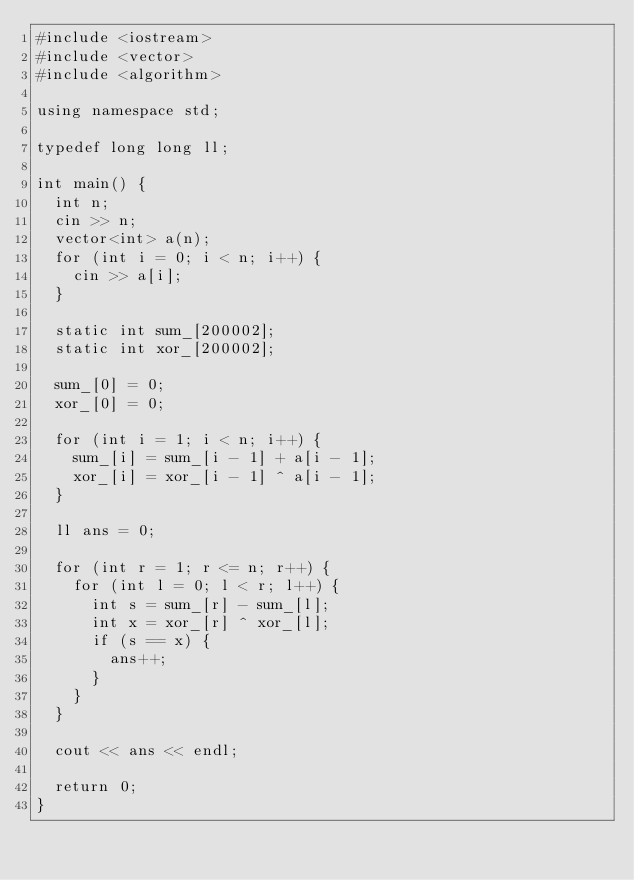Convert code to text. <code><loc_0><loc_0><loc_500><loc_500><_C++_>#include <iostream>
#include <vector>
#include <algorithm>

using namespace std;

typedef long long ll;

int main() {
  int n;
  cin >> n;
  vector<int> a(n);
  for (int i = 0; i < n; i++) {
    cin >> a[i];
  }

  static int sum_[200002];
  static int xor_[200002];
  
  sum_[0] = 0;
  xor_[0] = 0;

  for (int i = 1; i < n; i++) {
    sum_[i] = sum_[i - 1] + a[i - 1];
    xor_[i] = xor_[i - 1] ^ a[i - 1];
  }

  ll ans = 0;

  for (int r = 1; r <= n; r++) {
    for (int l = 0; l < r; l++) {
      int s = sum_[r] - sum_[l];
      int x = xor_[r] ^ xor_[l];
      if (s == x) {
        ans++;
      }
    }
  }

  cout << ans << endl;  

  return 0;
}</code> 